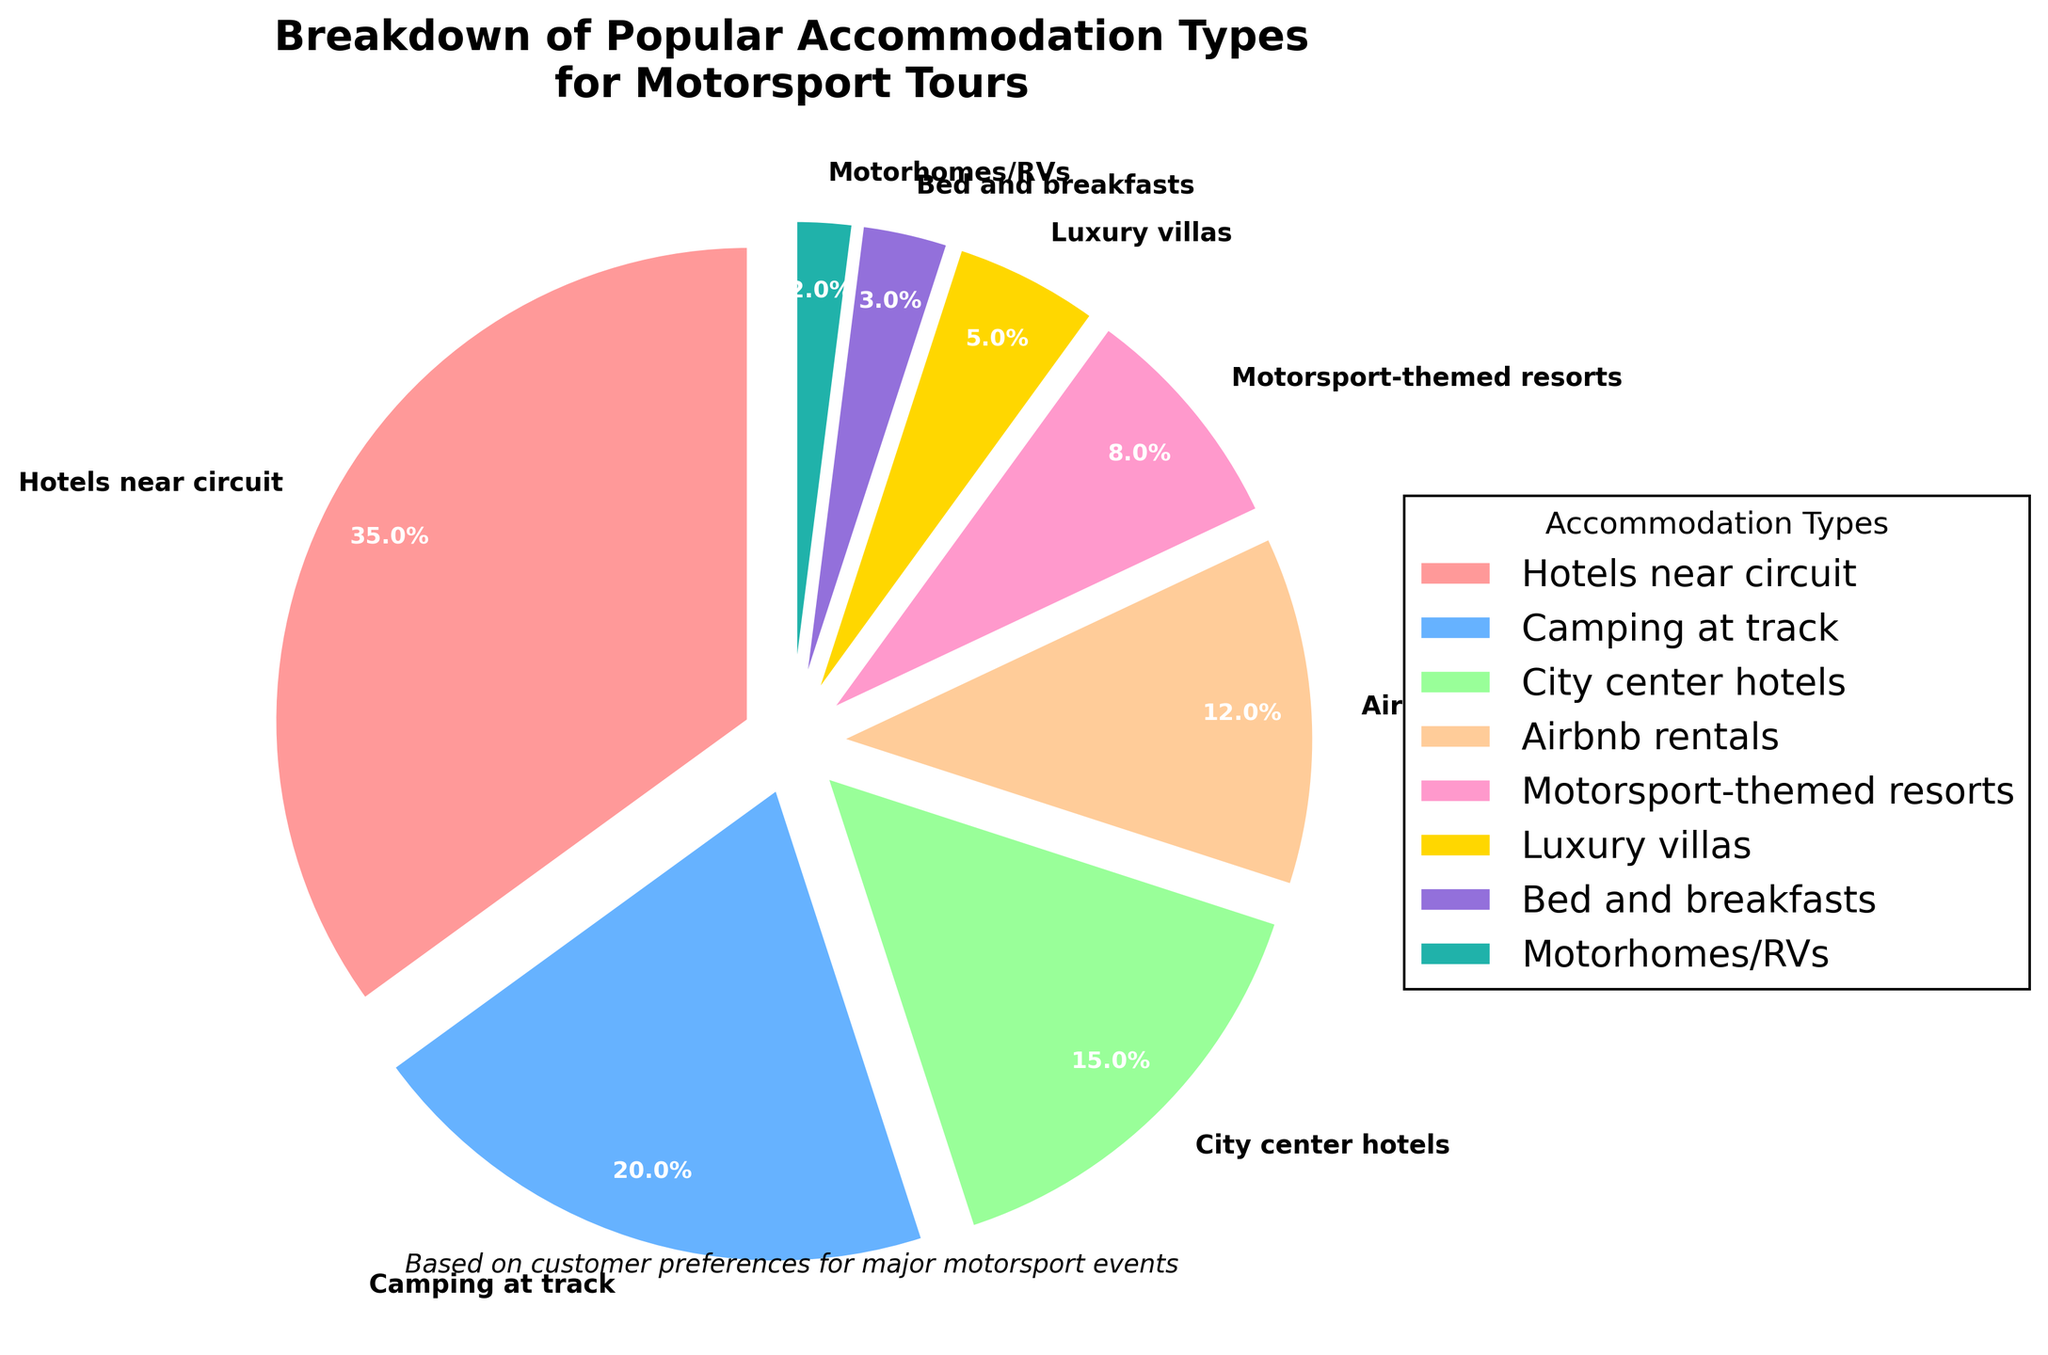Which accommodation type is the most popular for motorsport tours? The segment with the highest percentage represents the most popular accommodation type. The largest segment is 'Hotels near circuit' with 35%.
Answer: Hotels near circuit What is the combined percentage of people choosing camping at the track and city center hotels? Add the percentages for 'Camping at track' and 'City center hotels'. 20% + 15% = 35%.
Answer: 35% Which accommodation type is the least preferred? The segment with the smallest percentage represents the least preferred accommodation type. The smallest segment is 'Motorhomes/RVs' with 2%.
Answer: Motorhomes/RVs How much more popular are hotels near the circuit compared to luxury villas? Subtract the percentage of 'Luxury villas' from 'Hotels near circuit'. 35% - 5% = 30%.
Answer: 30% How do Airbnb rentals compare in popularity to city center hotels? Compare the percentages of those two segments. Airbnb rentals have 12% and city center hotels have 15%. Because 15% is greater than 12%, city center hotels are more popular.
Answer: City center hotels are more popular What percentage of people choose themed or specialized accommodation types (Motorsport-themed resorts and Motorhomes/RVs)? Sum the percentages of 'Motorsport-themed resorts' and 'Motorhomes/RVs'. 8% + 2% = 10%.
Answer: 10% What is the difference in preference between the top two accommodation types? Subtract the percentage of 'Camping at track' from 'Hotels near circuit'. 35% - 20% = 15%.
Answer: 15% Do more people choose Airbnb rentals or Bed and Breakfasts? Compare the percentages of the two segments. Airbnb rentals have 12% and Bed and Breakfasts have 3%.
Answer: Airbnb rentals What color represents city center hotels in the pie chart? Identify the color of the segment labeled 'City center hotels'.
Answer: Light pink What is the difference in preference between the least and most popular accommodation types? Subtract the percentage of 'Motorhomes/RVs' from 'Hotels near circuit'. 35% - 2% = 33%.
Answer: 33% 